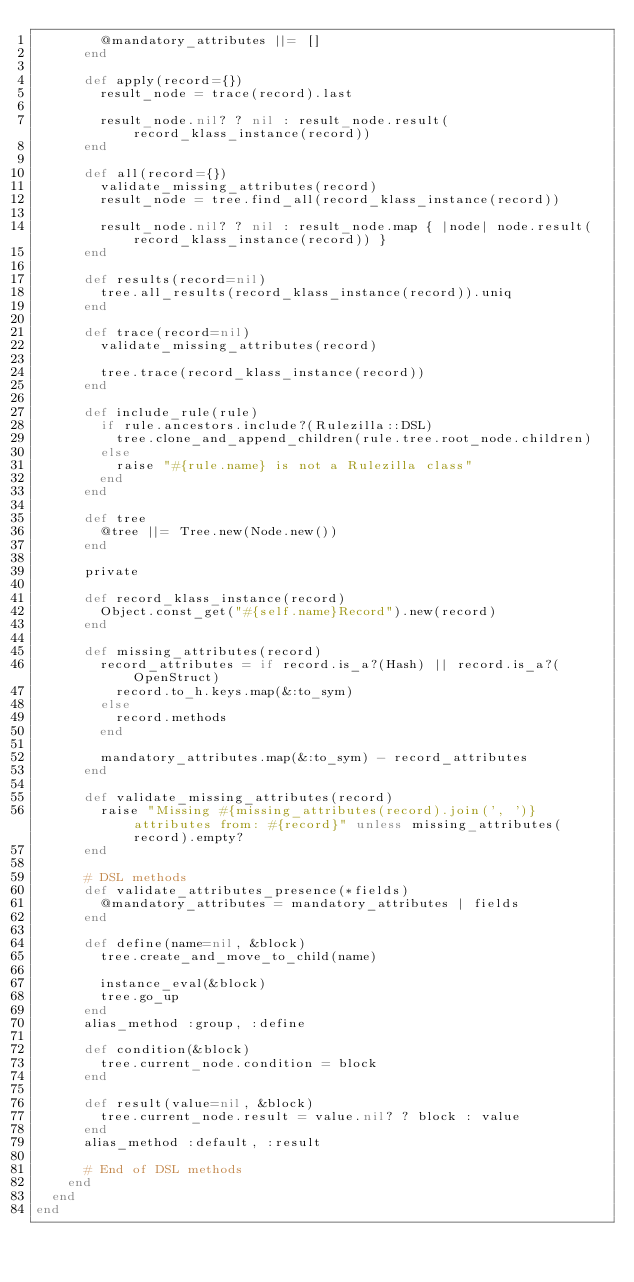Convert code to text. <code><loc_0><loc_0><loc_500><loc_500><_Ruby_>        @mandatory_attributes ||= []
      end

      def apply(record={})
        result_node = trace(record).last

        result_node.nil? ? nil : result_node.result(record_klass_instance(record))
      end

      def all(record={})
        validate_missing_attributes(record)
        result_node = tree.find_all(record_klass_instance(record))

        result_node.nil? ? nil : result_node.map { |node| node.result(record_klass_instance(record)) }
      end

      def results(record=nil)
        tree.all_results(record_klass_instance(record)).uniq
      end

      def trace(record=nil)
        validate_missing_attributes(record)

        tree.trace(record_klass_instance(record))
      end

      def include_rule(rule)
        if rule.ancestors.include?(Rulezilla::DSL)
          tree.clone_and_append_children(rule.tree.root_node.children)
        else
          raise "#{rule.name} is not a Rulezilla class"
        end
      end

      def tree
        @tree ||= Tree.new(Node.new())
      end

      private

      def record_klass_instance(record)
        Object.const_get("#{self.name}Record").new(record)
      end

      def missing_attributes(record)
        record_attributes = if record.is_a?(Hash) || record.is_a?(OpenStruct)
          record.to_h.keys.map(&:to_sym)
        else
          record.methods
        end

        mandatory_attributes.map(&:to_sym) - record_attributes
      end

      def validate_missing_attributes(record)
        raise "Missing #{missing_attributes(record).join(', ')} attributes from: #{record}" unless missing_attributes(record).empty?
      end

      # DSL methods
      def validate_attributes_presence(*fields)
        @mandatory_attributes = mandatory_attributes | fields
      end

      def define(name=nil, &block)
        tree.create_and_move_to_child(name)

        instance_eval(&block)
        tree.go_up
      end
      alias_method :group, :define

      def condition(&block)
        tree.current_node.condition = block
      end

      def result(value=nil, &block)
        tree.current_node.result = value.nil? ? block : value
      end
      alias_method :default, :result

      # End of DSL methods
    end
  end
end
</code> 